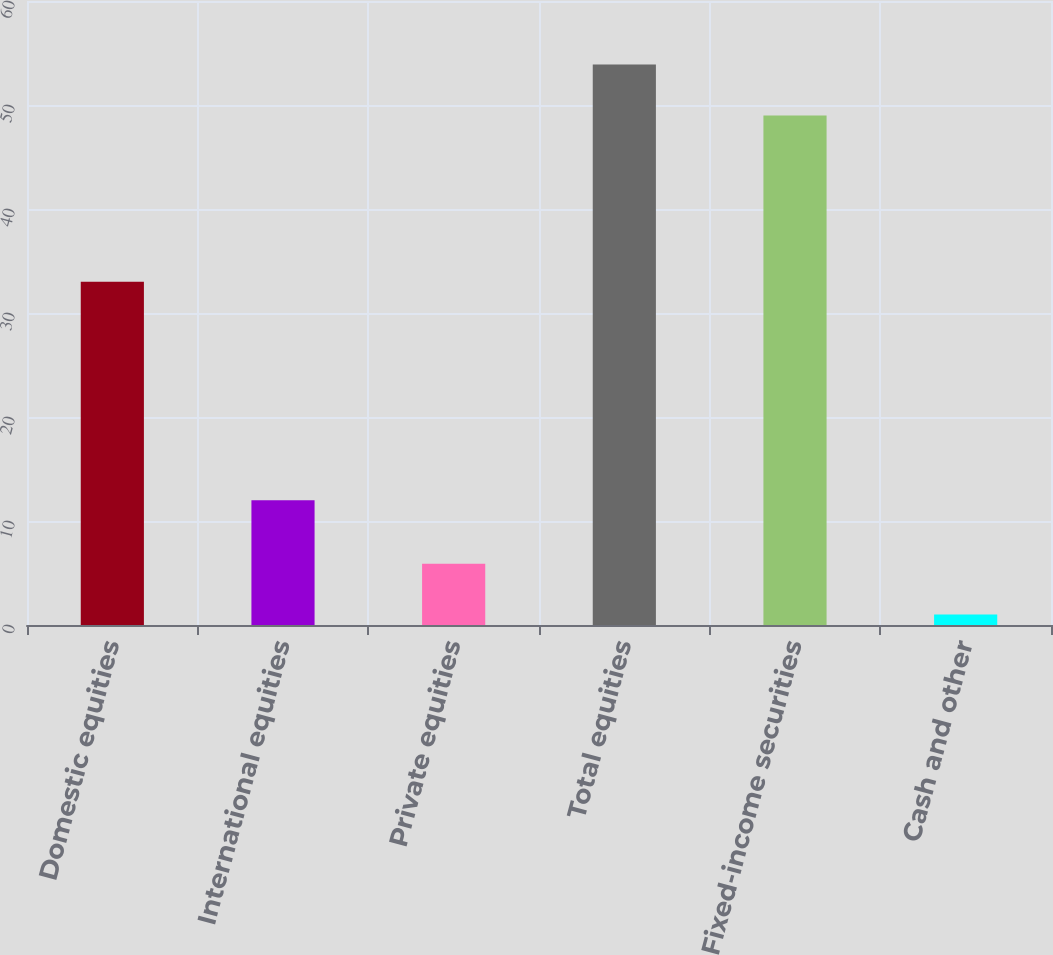<chart> <loc_0><loc_0><loc_500><loc_500><bar_chart><fcel>Domestic equities<fcel>International equities<fcel>Private equities<fcel>Total equities<fcel>Fixed-income securities<fcel>Cash and other<nl><fcel>33<fcel>12<fcel>5.9<fcel>53.9<fcel>49<fcel>1<nl></chart> 